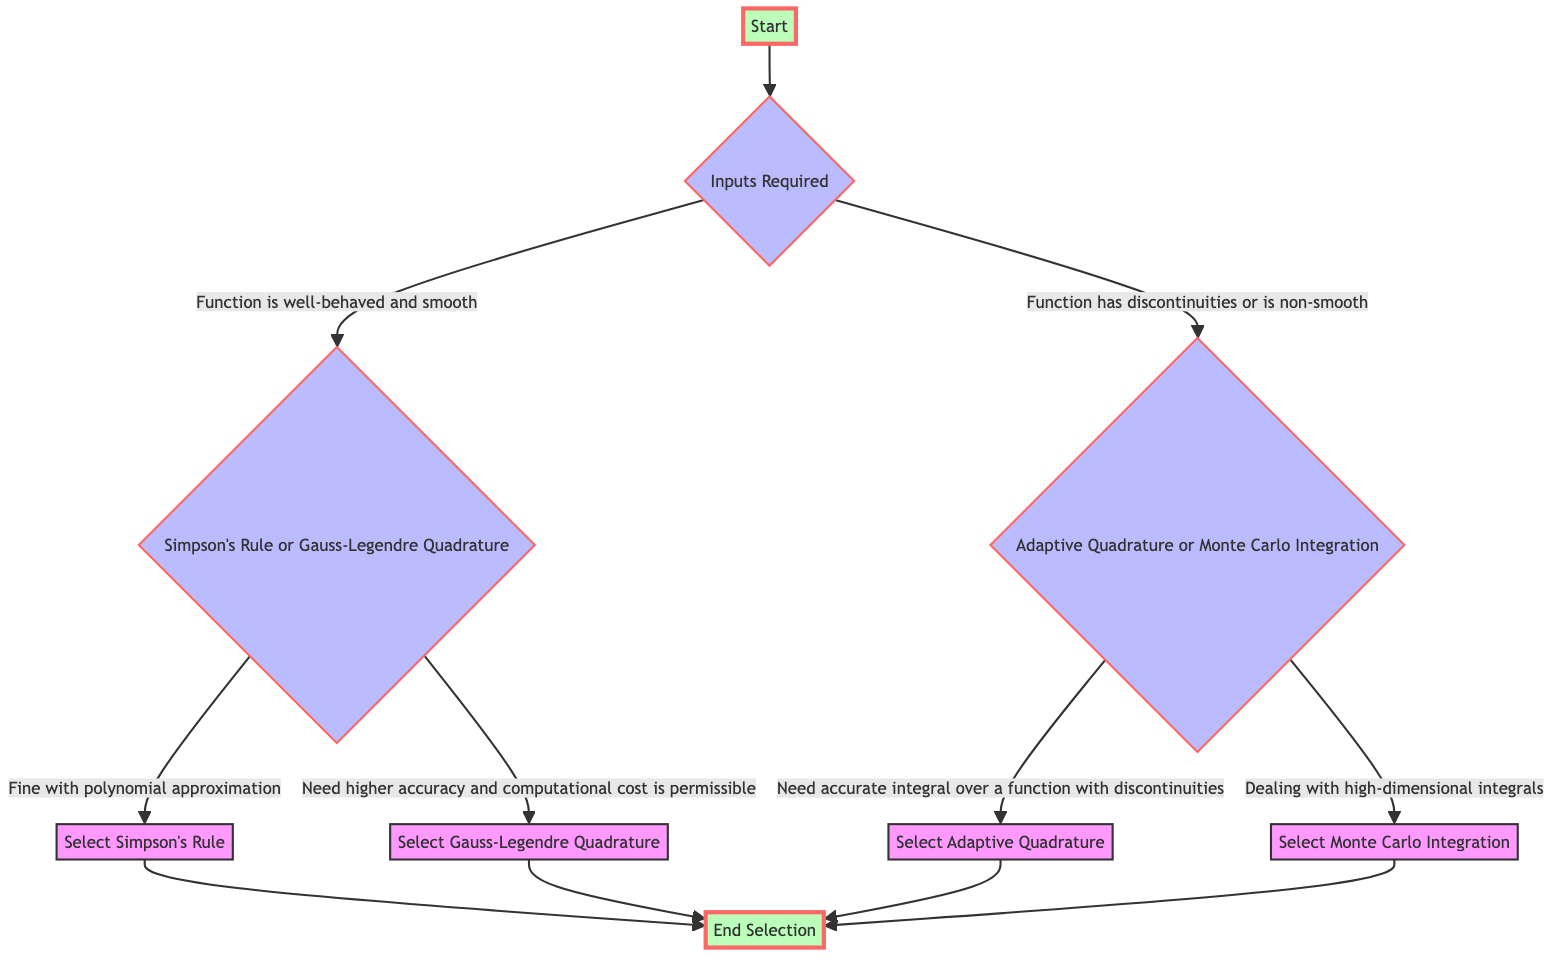What is the first node in the flowchart? The first node is labeled "Start," indicating the beginning of the selection process for numerical integration methods.
Answer: Start How many decision nodes are present in the diagram? There are three decision nodes: "Inputs Required," "Simpson's Rule or Gauss-Legendre Quadrature," and "Adaptive Quadrature or Monte Carlo Integration."
Answer: 3 What options are available if the function is well-behaved and smooth? The options are to consider either "Simpson's Rule" or "Gauss-Legendre Quadrature" based on the smoothness and behavior of the function.
Answer: Simpson's Rule or Gauss-Legendre Quadrature Which method is selected if the function has discontinuities? If the function has discontinuities, the method selected is "Adaptive Quadrature" for accurate integration over such functions.
Answer: Adaptive Quadrature If higher accuracy is needed and the computational cost is permissible, what is the next step? The next step would be to select "Gauss-Legendre Quadrature" when higher accuracy is necessary and the cost is not a concern.
Answer: Gauss-Legendre Quadrature What do you do if you are dealing with high-dimensional integrals? If dealing with high-dimensional integrals, the flowchart indicates that you should select "Monte Carlo Integration."
Answer: Monte Carlo Integration How does the flowchart conclude the selection process? The selection process concludes at the "End Selection" node after one of the methods has been selected based on the preceding decisions.
Answer: End Selection What needs to be checked for the numerical integration method selection? One needs to check the characteristics of the function and the desired accuracy to determine the appropriate method for integration.
Answer: Characteristics of the function and desired accuracy What is the purpose of the "Inputs Required" decision node? The "Inputs Required" decision node serves to evaluate the characteristics of the function to decide on the subsequent path in the selection process.
Answer: Evaluate function characteristics 